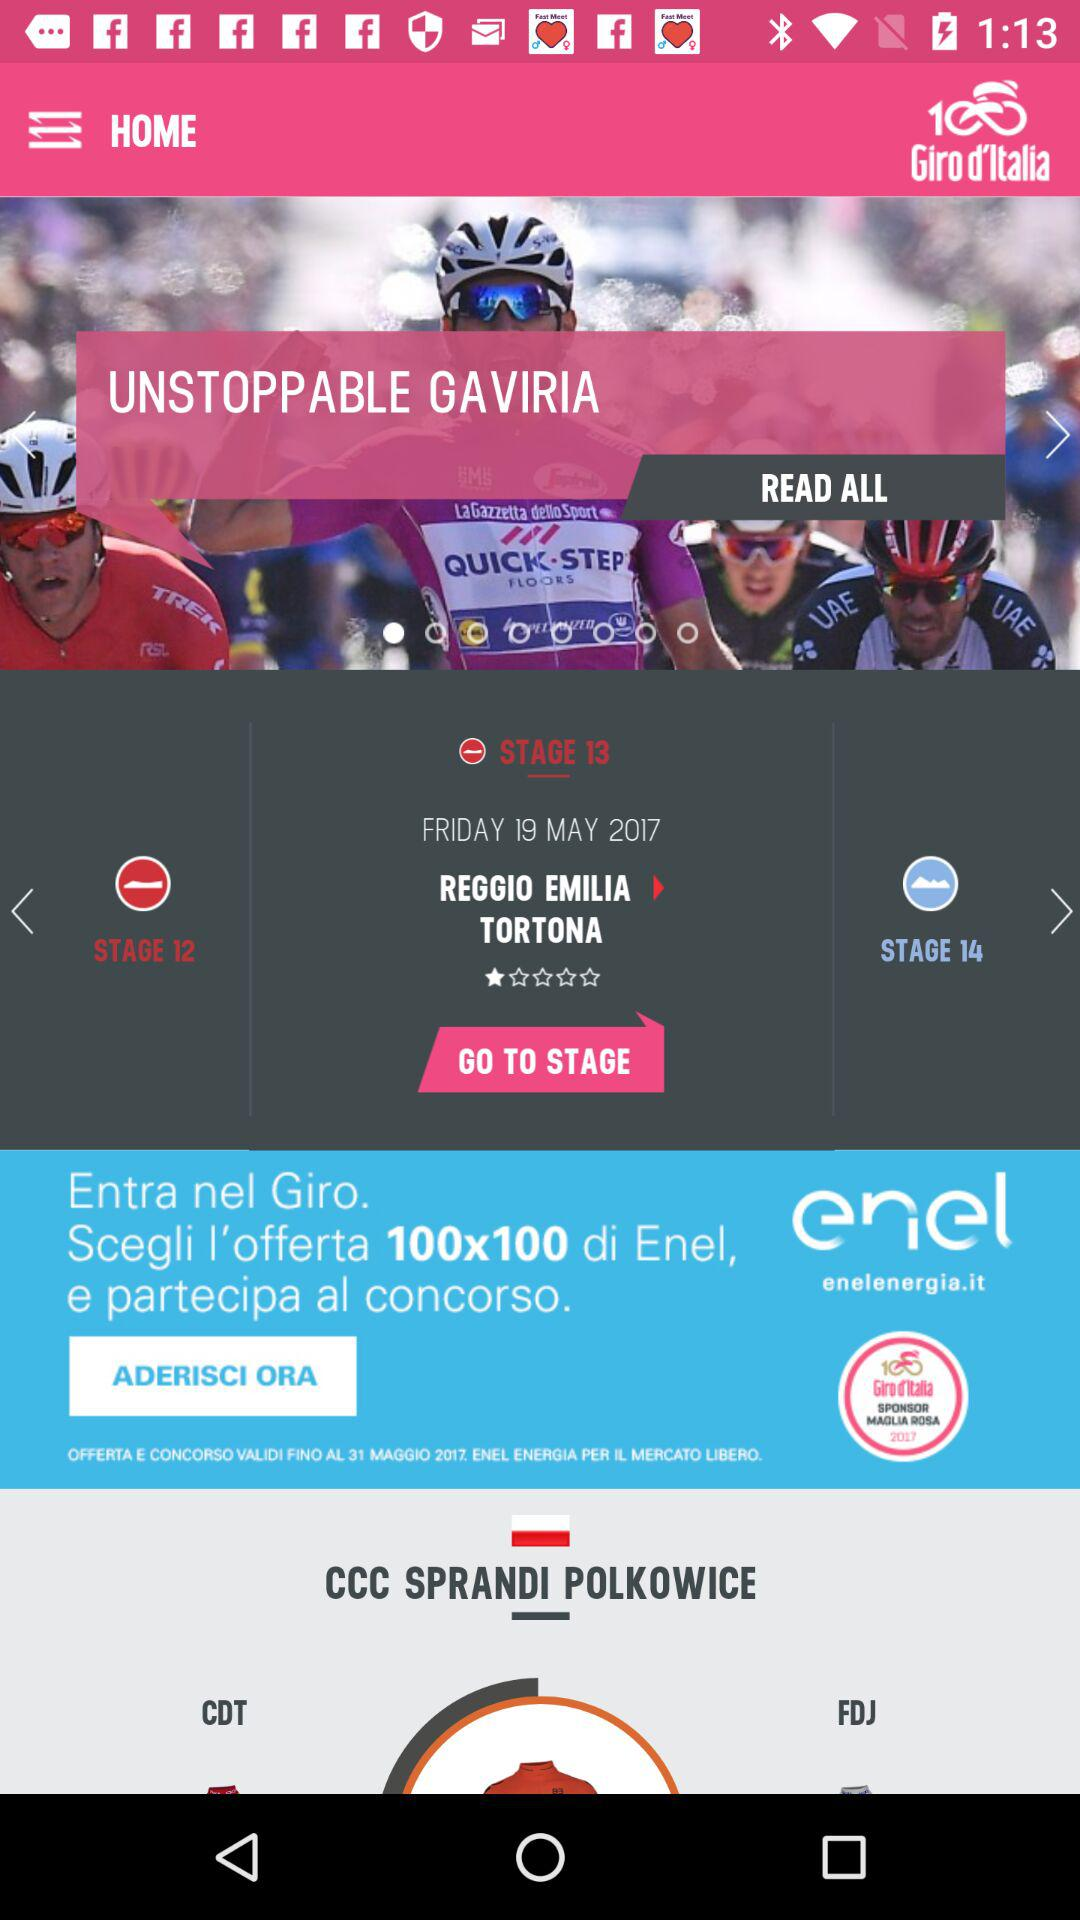How many stages are there in the race?
Answer the question using a single word or phrase. 14 